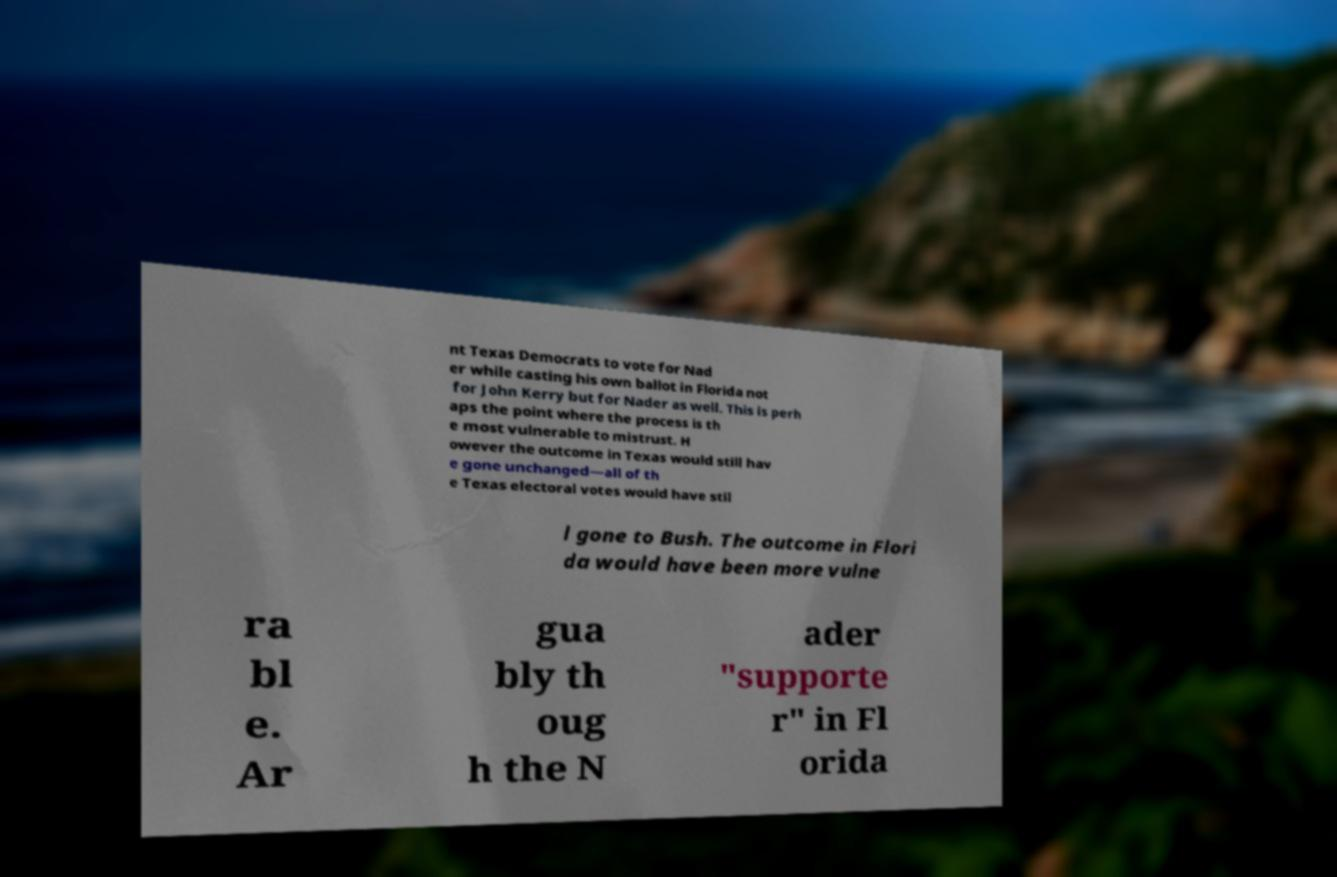I need the written content from this picture converted into text. Can you do that? nt Texas Democrats to vote for Nad er while casting his own ballot in Florida not for John Kerry but for Nader as well. This is perh aps the point where the process is th e most vulnerable to mistrust. H owever the outcome in Texas would still hav e gone unchanged—all of th e Texas electoral votes would have stil l gone to Bush. The outcome in Flori da would have been more vulne ra bl e. Ar gua bly th oug h the N ader "supporte r" in Fl orida 